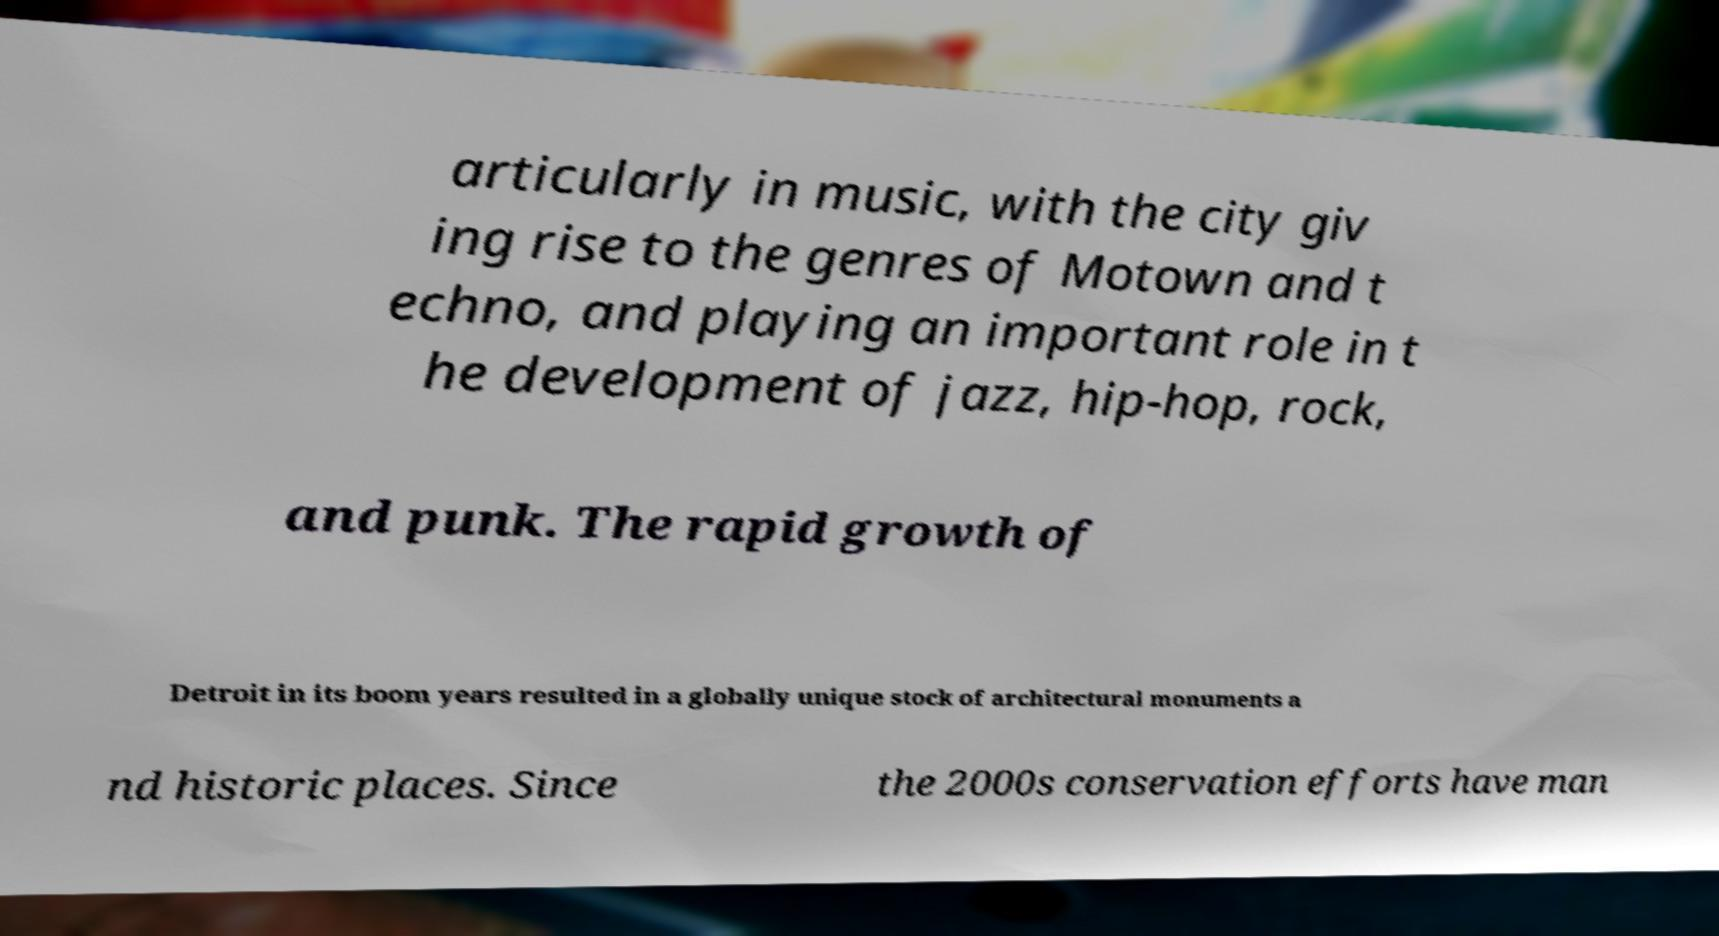Please read and relay the text visible in this image. What does it say? articularly in music, with the city giv ing rise to the genres of Motown and t echno, and playing an important role in t he development of jazz, hip-hop, rock, and punk. The rapid growth of Detroit in its boom years resulted in a globally unique stock of architectural monuments a nd historic places. Since the 2000s conservation efforts have man 